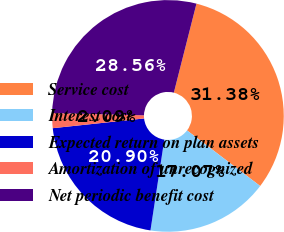Convert chart to OTSL. <chart><loc_0><loc_0><loc_500><loc_500><pie_chart><fcel>Service cost<fcel>Interest cost<fcel>Expected return on plan assets<fcel>Amortization of unrecognized<fcel>Net periodic benefit cost<nl><fcel>31.38%<fcel>17.07%<fcel>20.9%<fcel>2.09%<fcel>28.56%<nl></chart> 